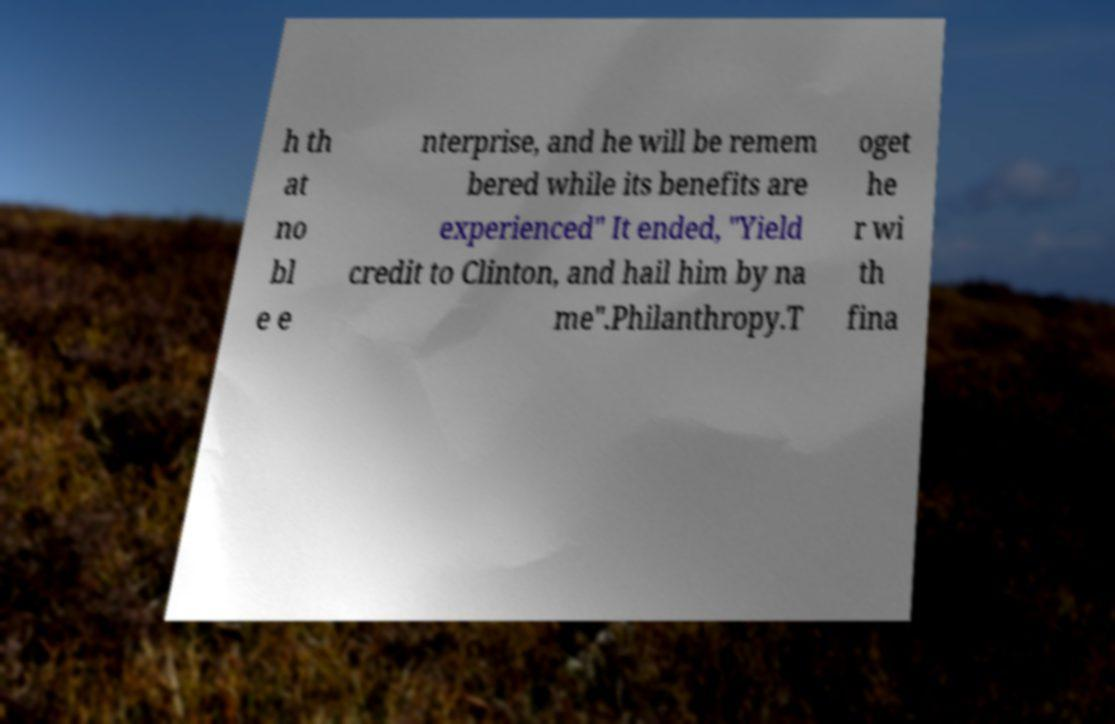For documentation purposes, I need the text within this image transcribed. Could you provide that? h th at no bl e e nterprise, and he will be remem bered while its benefits are experienced" It ended, "Yield credit to Clinton, and hail him by na me".Philanthropy.T oget he r wi th fina 